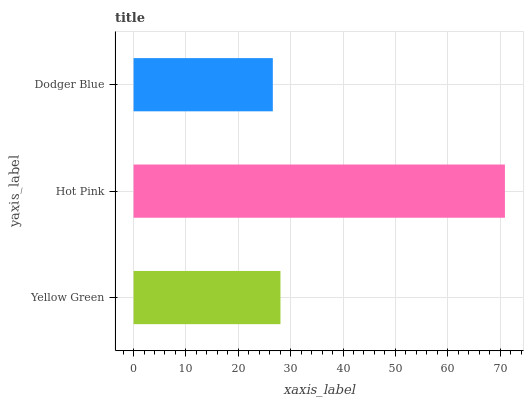Is Dodger Blue the minimum?
Answer yes or no. Yes. Is Hot Pink the maximum?
Answer yes or no. Yes. Is Hot Pink the minimum?
Answer yes or no. No. Is Dodger Blue the maximum?
Answer yes or no. No. Is Hot Pink greater than Dodger Blue?
Answer yes or no. Yes. Is Dodger Blue less than Hot Pink?
Answer yes or no. Yes. Is Dodger Blue greater than Hot Pink?
Answer yes or no. No. Is Hot Pink less than Dodger Blue?
Answer yes or no. No. Is Yellow Green the high median?
Answer yes or no. Yes. Is Yellow Green the low median?
Answer yes or no. Yes. Is Dodger Blue the high median?
Answer yes or no. No. Is Dodger Blue the low median?
Answer yes or no. No. 